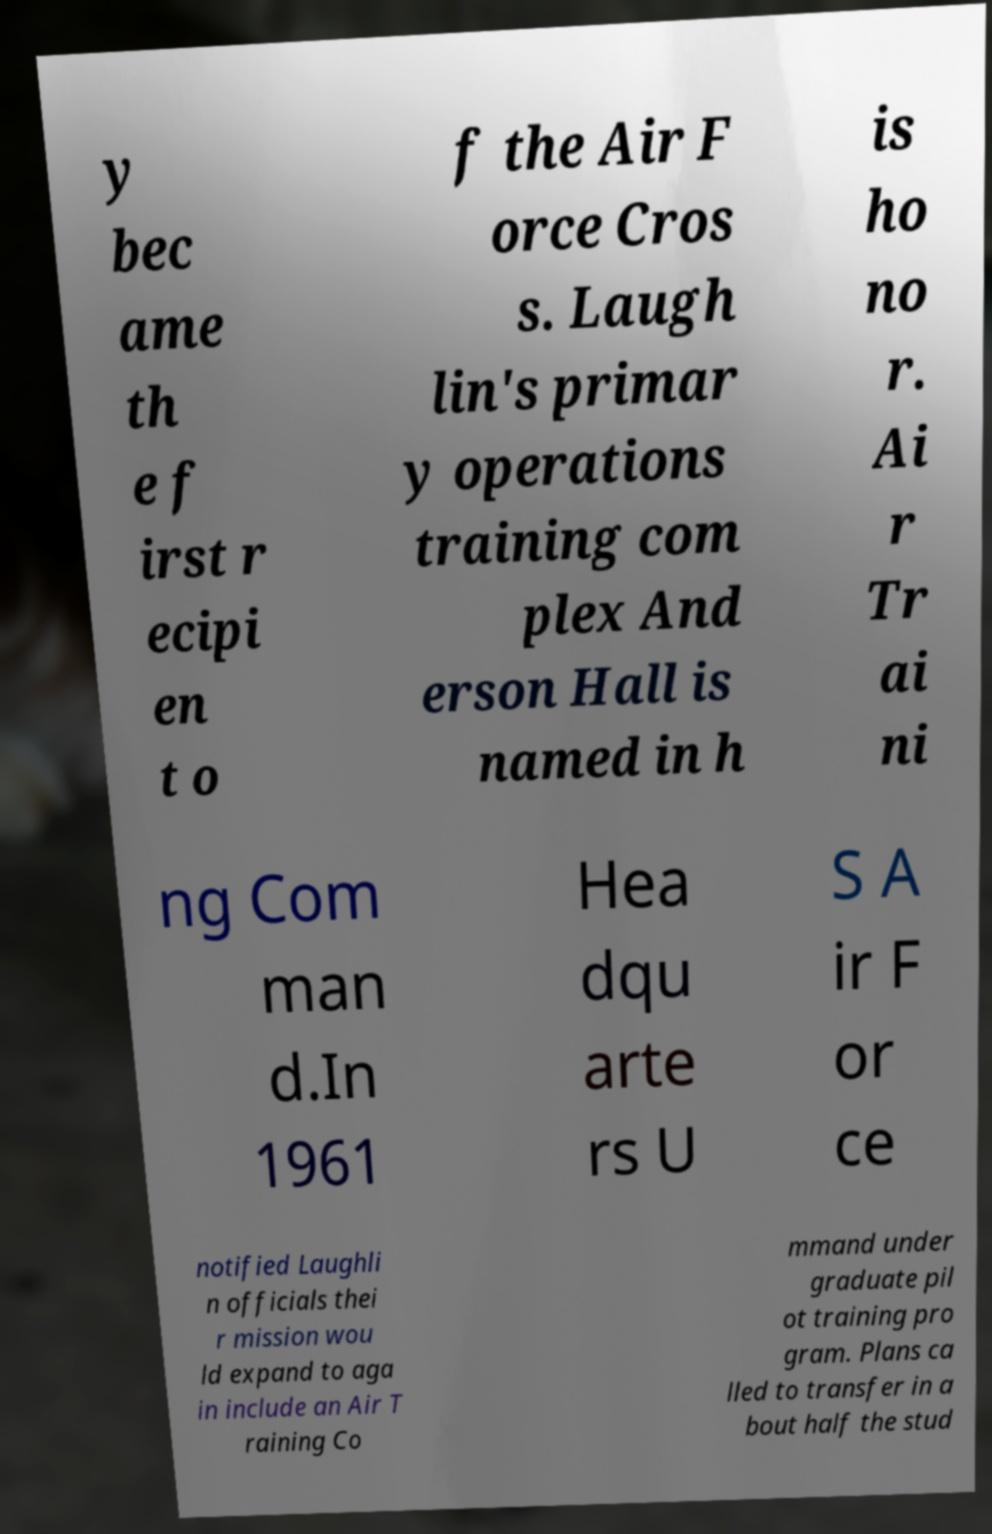Can you accurately transcribe the text from the provided image for me? y bec ame th e f irst r ecipi en t o f the Air F orce Cros s. Laugh lin's primar y operations training com plex And erson Hall is named in h is ho no r. Ai r Tr ai ni ng Com man d.In 1961 Hea dqu arte rs U S A ir F or ce notified Laughli n officials thei r mission wou ld expand to aga in include an Air T raining Co mmand under graduate pil ot training pro gram. Plans ca lled to transfer in a bout half the stud 